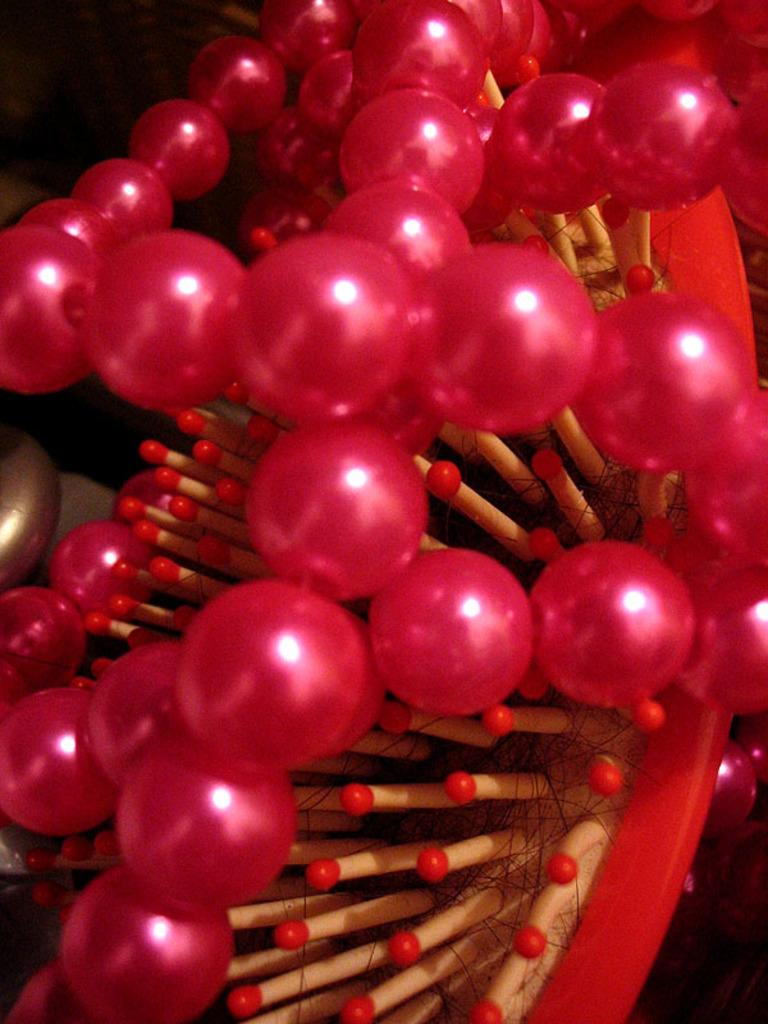What object can be seen in the image? There is a hair comb in the image. What colors are present on the hair comb? The hair comb has cream and red colors. What additional feature is present on the hair comb? There is a pearl chain on the hair comb. What color is the pearl chain? The pearl chain has a pink color. What can be observed about the background of the image? The background of the image is black. How does the hair comb show approval for the turkey in the image? There is no turkey present in the image, and the hair comb does not express approval or disapproval. 